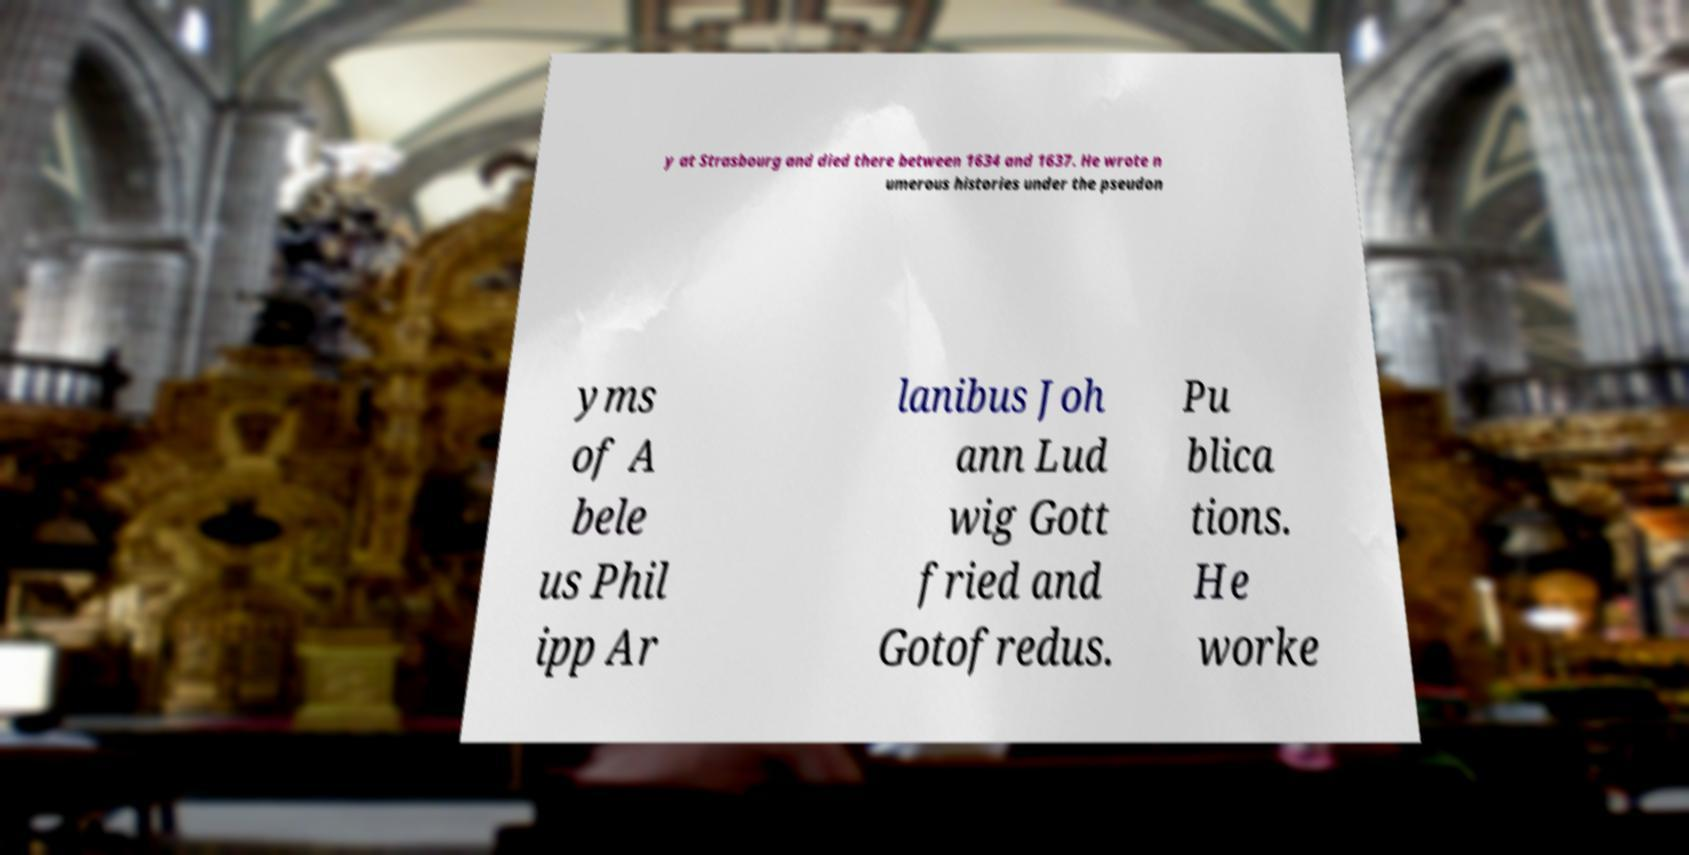Please identify and transcribe the text found in this image. y at Strasbourg and died there between 1634 and 1637. He wrote n umerous histories under the pseudon yms of A bele us Phil ipp Ar lanibus Joh ann Lud wig Gott fried and Gotofredus. Pu blica tions. He worke 